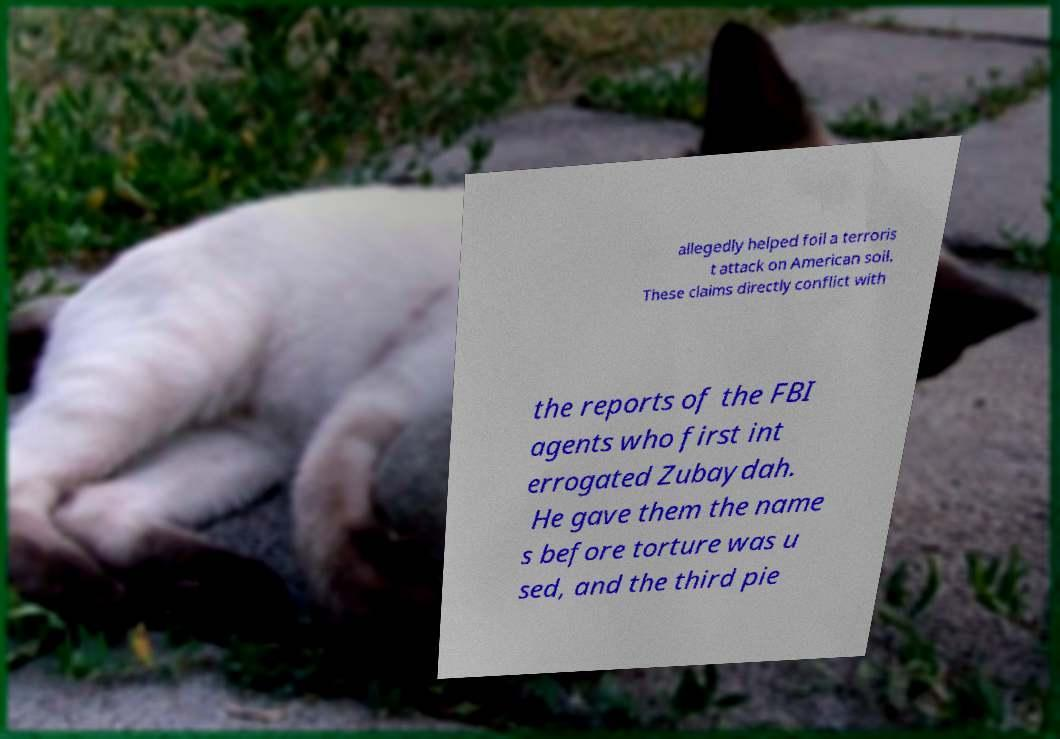I need the written content from this picture converted into text. Can you do that? allegedly helped foil a terroris t attack on American soil. These claims directly conflict with the reports of the FBI agents who first int errogated Zubaydah. He gave them the name s before torture was u sed, and the third pie 